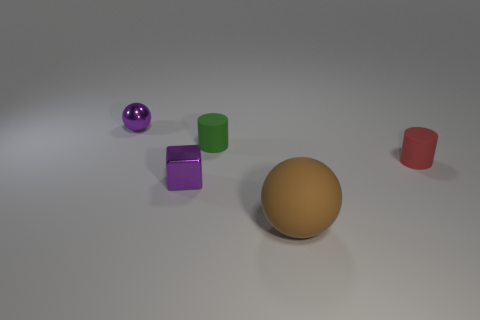Are there any small metal things that have the same color as the metal ball?
Provide a succinct answer. Yes. Do the cube and the large object have the same material?
Give a very brief answer. No. Does the tiny cube have the same color as the small metallic ball?
Offer a terse response. Yes. Are there fewer purple metallic balls that are on the left side of the small purple metal ball than small purple matte spheres?
Your answer should be compact. No. Is there any other thing that is the same size as the brown rubber sphere?
Your answer should be compact. No. There is a purple metallic thing that is on the right side of the shiny object behind the red rubber cylinder; what is its size?
Your response must be concise. Small. Is there anything else that is the same shape as the tiny green matte thing?
Offer a terse response. Yes. Is the number of red things less than the number of large yellow rubber spheres?
Make the answer very short. No. There is a object that is both in front of the tiny red matte thing and behind the large brown ball; what is it made of?
Offer a terse response. Metal. Is there a brown rubber thing that is behind the matte cylinder on the left side of the large brown matte sphere?
Offer a terse response. No. 